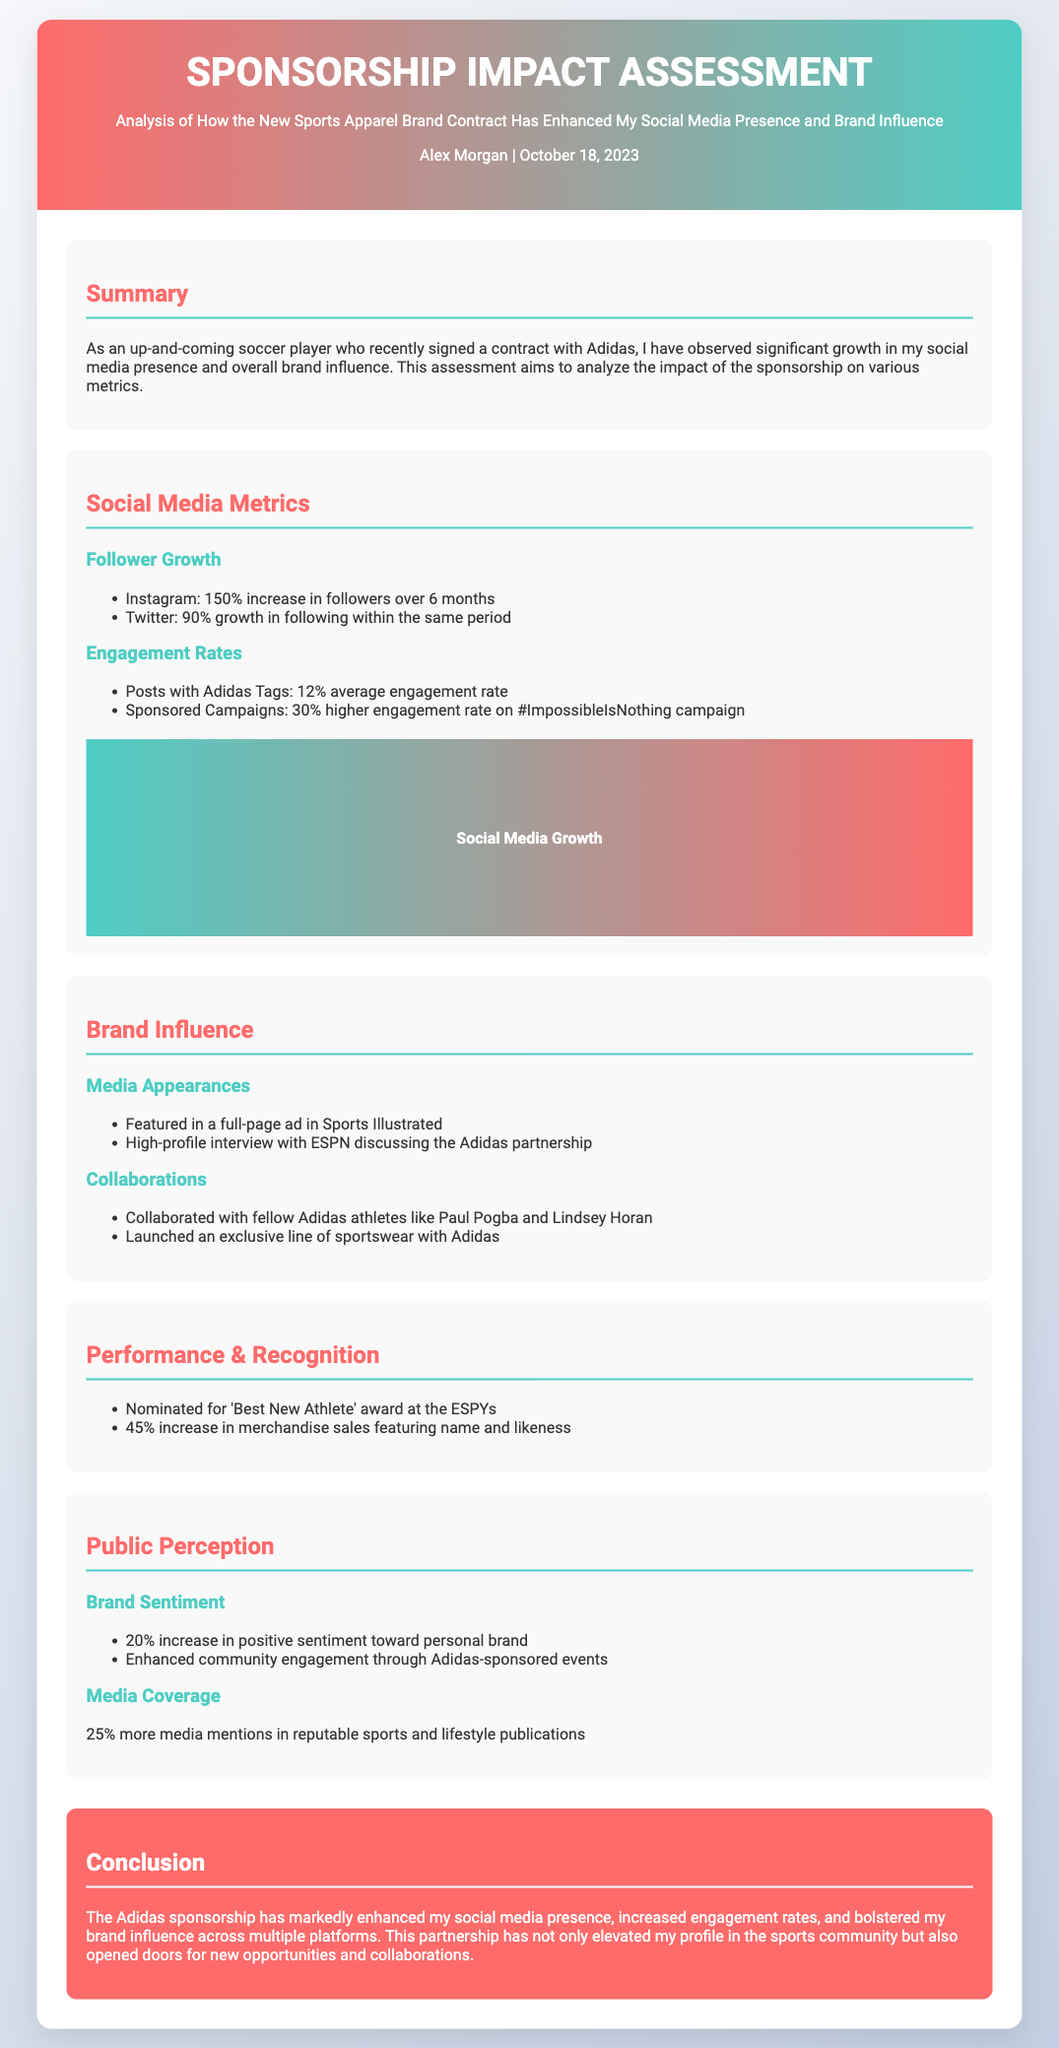What is the follower growth on Instagram? The document states a 150% increase in followers on Instagram over 6 months.
Answer: 150% What was the increase in merchandise sales? The document mentions a 45% increase in merchandise sales featuring name and likeness.
Answer: 45% Which campaign had a higher engagement rate? The document highlights that sponsored campaigns had a 30% higher engagement rate on the #ImpossibleIsNothing campaign.
Answer: #ImpossibleIsNothing How many athletes collaborated with Adidas? The document lists collaborations with fellow Adidas athletes like Paul Pogba and Lindsey Horan, indicating at least two collaborations.
Answer: Two What is the percentage increase in positive sentiment? The document indicates a 20% increase in positive sentiment toward the personal brand.
Answer: 20% Which publication featured a full-page ad? The document notes that the athlete was featured in a full-page ad in Sports Illustrated.
Answer: Sports Illustrated What was the date of this assessment? The document specifies that the assessment was made on October 18, 2023.
Answer: October 18, 2023 What kind of events enhanced community engagement? The document mentions Adidas-sponsored events enhanced community engagement.
Answer: Adidas-sponsored events What award was the athlete nominated for? The document states that the athlete was nominated for the 'Best New Athlete' award at the ESPYs.
Answer: Best New Athlete 